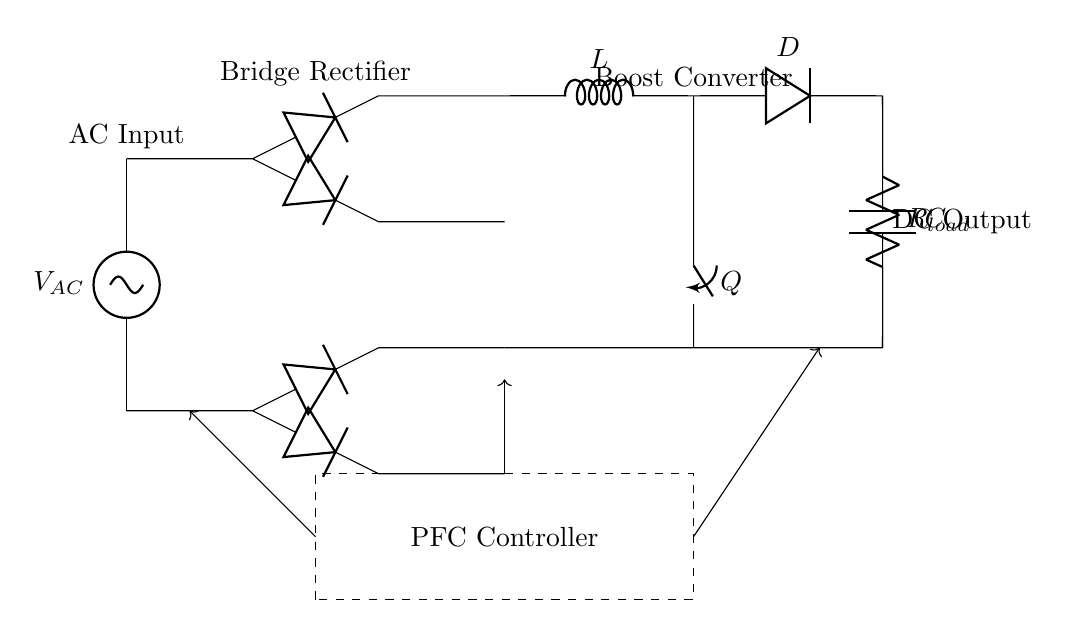What is the input type of this circuit? The circuit diagram shows an AC source labeled as V_AC at the top, indicating that the input is alternating current.
Answer: AC What components make up the bridge rectifier? The bridge rectifier consists of four diodes, which are used to convert AC voltage to DC by allowing current to flow in one direction. The diagram shows the arrangement of these diodes.
Answer: Four diodes What is the role of the inductance in this circuit? The inductor, labeled L, in the boost converter section is used to store energy and smooth the current as it converts the lower voltage from the rectifier into a higher voltage output for the load.
Answer: Energy storage How does the PFC controller interact with the circuit? The dashed rectangle represents the PFC controller, which monitors and adjusts the circuit's power factor by controlling the operation of the switch Q and ensuring that it maintains efficient energy usage. The arrows indicate data flow.
Answer: Adjusts power factor What happens if the switch Q is open? If switch Q is open, then the energy stored in the inductor will not be released to the load, resulting in no output from the boost converter and thus no DC voltage supplied to the load.
Answer: No output What type of load is indicated in this circuit? The load is represented by the resistor labeled R_load. This signifies that the circuit is designed to power resistive loads, such as heating elements or motor coils often found in refrigerators.
Answer: Resistive load 